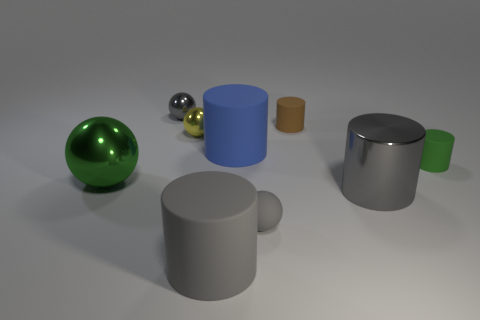Subtract all gray metallic cylinders. How many cylinders are left? 4 Subtract all blue cylinders. How many cylinders are left? 4 Subtract all red cylinders. Subtract all green spheres. How many cylinders are left? 5 Add 1 big purple cylinders. How many objects exist? 10 Subtract all cylinders. How many objects are left? 4 Subtract all big rubber objects. Subtract all green shiny things. How many objects are left? 6 Add 3 large gray things. How many large gray things are left? 5 Add 8 tiny rubber cylinders. How many tiny rubber cylinders exist? 10 Subtract 0 yellow blocks. How many objects are left? 9 